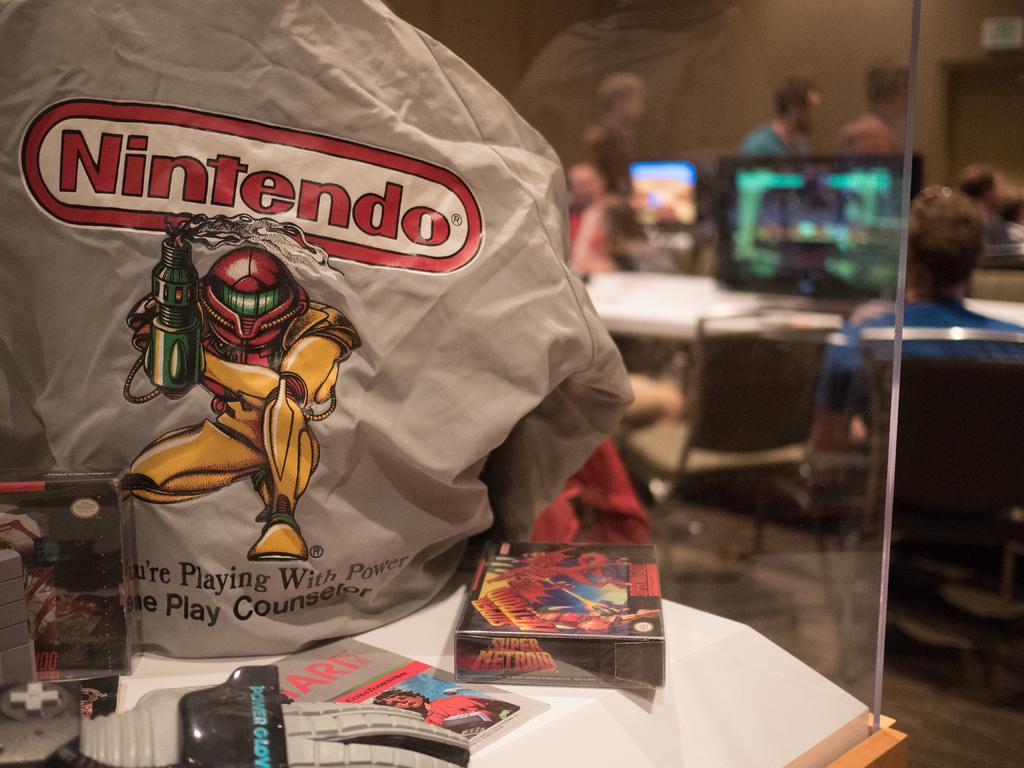How would you summarize this image in a sentence or two? In this picture I can see there is a table, I can see there are few objects and there is a shirt, there is an image and something written on it. There are a few people sitting at the right side and there are computers placed on the table. 